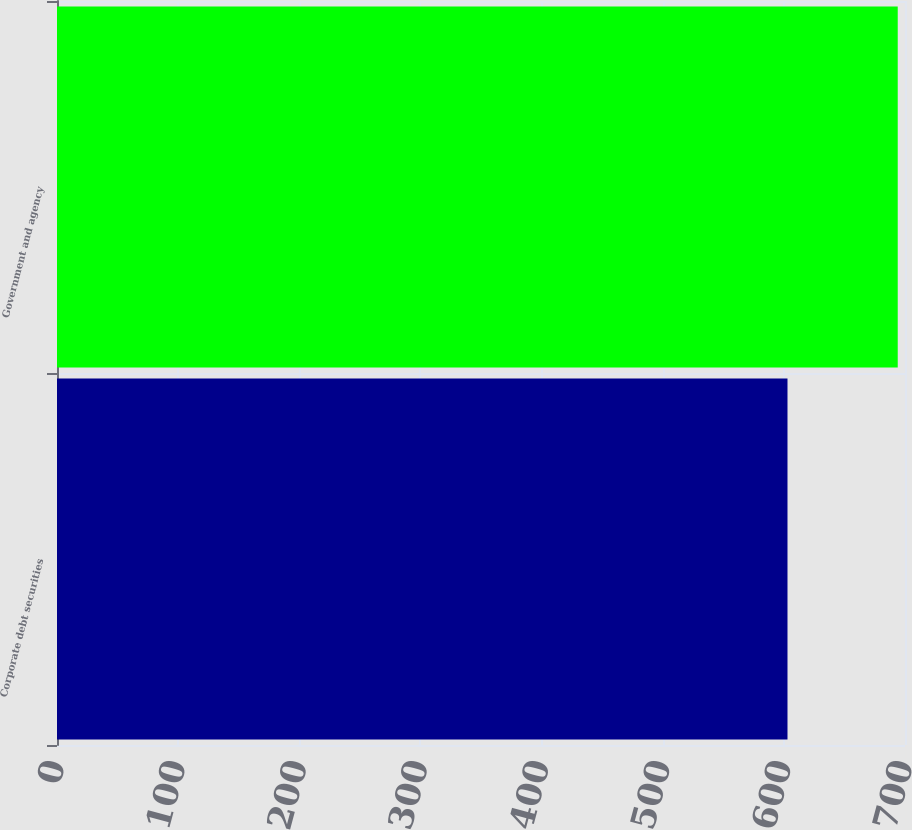Convert chart. <chart><loc_0><loc_0><loc_500><loc_500><bar_chart><fcel>Corporate debt securities<fcel>Government and agency<nl><fcel>603<fcel>694<nl></chart> 